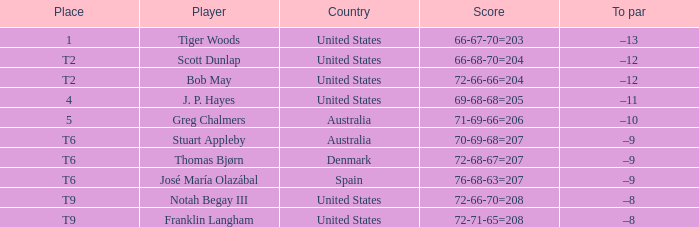What is the homeland of the player holding a t6 spot? Australia, Denmark, Spain. Give me the full table as a dictionary. {'header': ['Place', 'Player', 'Country', 'Score', 'To par'], 'rows': [['1', 'Tiger Woods', 'United States', '66-67-70=203', '–13'], ['T2', 'Scott Dunlap', 'United States', '66-68-70=204', '–12'], ['T2', 'Bob May', 'United States', '72-66-66=204', '–12'], ['4', 'J. P. Hayes', 'United States', '69-68-68=205', '–11'], ['5', 'Greg Chalmers', 'Australia', '71-69-66=206', '–10'], ['T6', 'Stuart Appleby', 'Australia', '70-69-68=207', '–9'], ['T6', 'Thomas Bjørn', 'Denmark', '72-68-67=207', '–9'], ['T6', 'José María Olazábal', 'Spain', '76-68-63=207', '–9'], ['T9', 'Notah Begay III', 'United States', '72-66-70=208', '–8'], ['T9', 'Franklin Langham', 'United States', '72-71-65=208', '–8']]} 